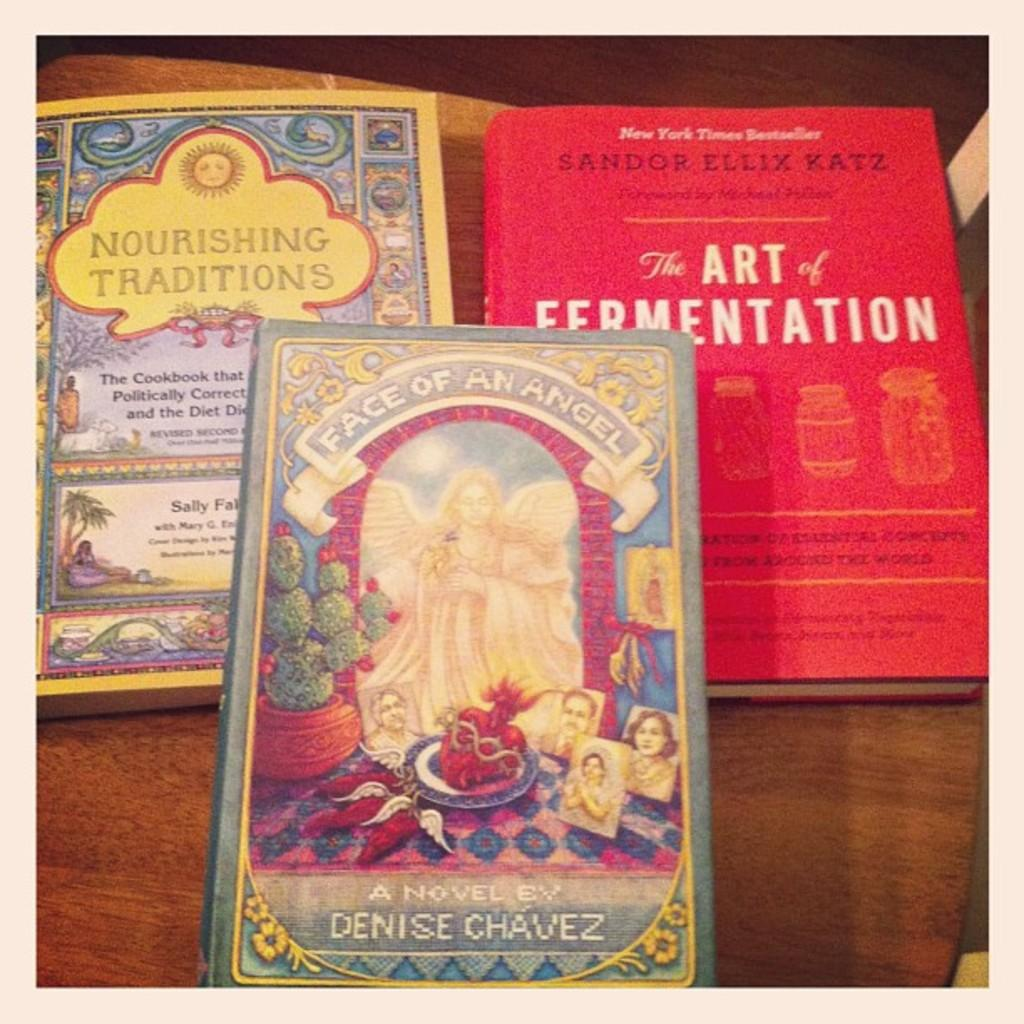<image>
Render a clear and concise summary of the photo. A book with the words NOURISHING TRADITIONS lays on a table. 